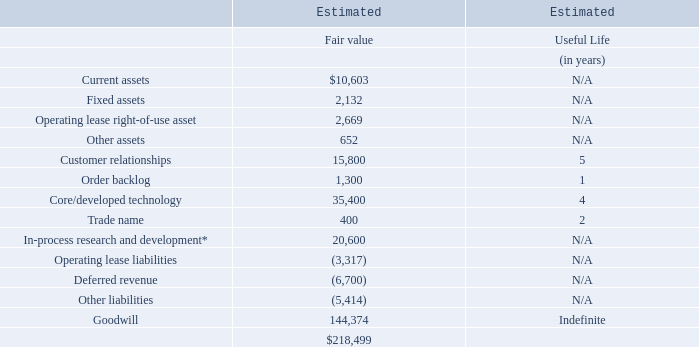Proofpoint, Inc. Notes to Consolidated Financial Statements (Continued) (dollars and share amounts in thousands, except per share amounts)
Also, as part of the share purchase agreement, the unvested restricted shares of a certain employee of ObserveIT were exchanged into the right to receive $532 of deferred cash consideration. The deferred cash consideration is presented as restricted cash on the Company’s consolidated balance sheet. The deferred cash consideration of $485 was allocated to post-combination expense and was not included in the purchase price. The deferred cash consideration is subject to forfeiture if employment terminates prior to the lapse of the restrictions, and the fair value is expensed as compensation expense over the three-year vesting period.
The Discounted Cash Flow Method was used to value the acquired developed technology, in-process research and development asset, customer relationships and order backlog. The Relief from Royalty Method was used to value the acquired trade name. Management applied significant judgment in estimating the fair values of these intangible assets, which involved the use of significant assumptions with respect to forecasted revenue, forecasted operating results and discount rates.
The following table summarizes the fair values of tangible assets acquired, liabilities assumed, intangible assets and goodwill:
*Purchased in-process research and development will be accounted for as an indefinite-lived intangible asset until the underlying project is completed or abandoned.
Meta Networks, Ltd.
On May 15, 2019 (the “Meta Networks Acquisition Date”), pursuant to the terms of the share purchase agreement, the Company acquired all shares of Meta Networks, Ltd. (“Meta Networks”), an innovator in zero trust network access.
By combining Meta Networks’ innovative zero trust network access technology with the Company’s people-centric security capabilities the Company expects to make it far simpler for enterprises to precisely control employee and contractor access to on-premises, cloud and consumer applications.
These factors, among others, contributed to a purchase price in excess of the estimated fair value of acquired net identifiable assets and, as a result, goodwill was recorded in connection with the acquisition. The results of operations and the fair values of the acquired assets and liabilities assumed have been included in the accompanying consolidated financial statements since the Meta Networks Acquisition Date.  These factors, among others, contributed to a purchase price in excess of the estimated fair value of acquired net identifiable assets and, as a result, goodwill was recorded in connection with the acquisition. The results of operations and the fair values of the acquired assets and liabilities assumed have been included in the accompanying consolidated financial statements since the Meta Networks Acquisition Date.
At the Meta Networks Acquisition Date, the consideration transferred was $104,664, net of cash acquired of $104. Of the consideration transferred, $12,500 was held in escrow to secure indemnification obligations, which has not been released as of the issuance of these consolidated financial statements. The revenue from Meta Networks was not material in 2019, and due to the continued integration of the combined businesses, it was impractical to determine the earnings.
How did Proofpoint Inc make it easier for enterprises to accurately control employees and contractor access to on-premises, cloud and consumer application?   Combining meta networks’ innovative zero trust network access technology with the company’s people-centric security capabilities. What method was used to value the acquired technology, in-process research and development assests?  Discounted cash flow method. Which subject has the highest estimated useful life? Goodwill. What is the difference in estimated fair value between current assets and fixed assets?
Answer scale should be: thousand. $10,603 - 2,132
Answer: 8471. What is the average estimated fair value of Customer relationships?
Answer scale should be: thousand. 15,800 / 5
Answer: 3160. What is the total estimated fair value of all assets?
Answer scale should be: thousand. $10,603 + 2,132 + 2,669 + 652 + 15,800 + 1,300 + 35,400 + 400 + 20,600
Answer: 89556. 